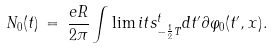<formula> <loc_0><loc_0><loc_500><loc_500>N _ { 0 } ( t ) \, = \, \frac { e R } { 2 \pi } \int \lim i t s _ { - \frac { 1 } { 2 } T } ^ { t } d t ^ { \prime } \partial { \varphi _ { 0 } } ( t ^ { \prime } , x ) .</formula> 